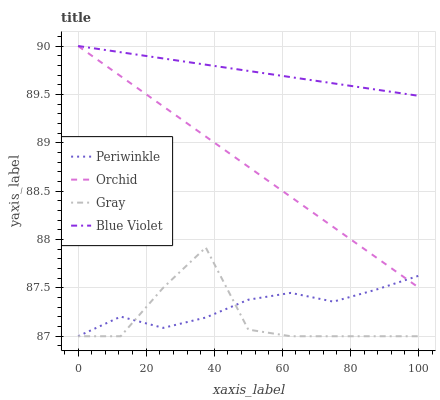Does Gray have the minimum area under the curve?
Answer yes or no. Yes. Does Blue Violet have the maximum area under the curve?
Answer yes or no. Yes. Does Periwinkle have the minimum area under the curve?
Answer yes or no. No. Does Periwinkle have the maximum area under the curve?
Answer yes or no. No. Is Orchid the smoothest?
Answer yes or no. Yes. Is Gray the roughest?
Answer yes or no. Yes. Is Periwinkle the smoothest?
Answer yes or no. No. Is Periwinkle the roughest?
Answer yes or no. No. Does Gray have the lowest value?
Answer yes or no. Yes. Does Blue Violet have the lowest value?
Answer yes or no. No. Does Orchid have the highest value?
Answer yes or no. Yes. Does Periwinkle have the highest value?
Answer yes or no. No. Is Periwinkle less than Blue Violet?
Answer yes or no. Yes. Is Blue Violet greater than Periwinkle?
Answer yes or no. Yes. Does Orchid intersect Blue Violet?
Answer yes or no. Yes. Is Orchid less than Blue Violet?
Answer yes or no. No. Is Orchid greater than Blue Violet?
Answer yes or no. No. Does Periwinkle intersect Blue Violet?
Answer yes or no. No. 